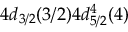<formula> <loc_0><loc_0><loc_500><loc_500>4 d _ { 3 / 2 } ( 3 / 2 ) 4 d _ { 5 / 2 } ^ { 4 } ( 4 )</formula> 